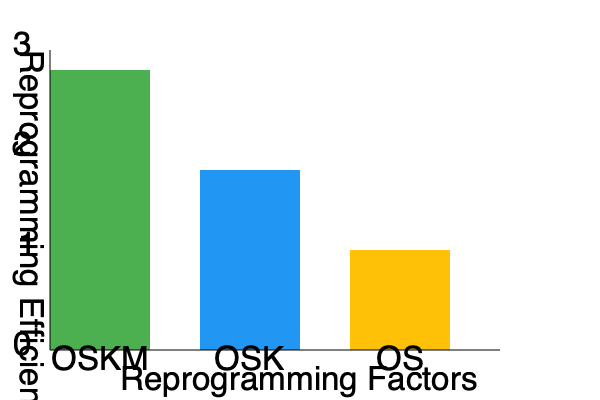Based on the bar chart showing the reprogramming efficiency of different factor combinations, which of the following statements is correct regarding the OSKM (Oct4, Sox2, Klf4, c-Myc) combination compared to the other factor combinations? To answer this question, we need to analyze the bar chart and compare the reprogramming efficiencies of the different factor combinations:

1. Identify the factor combinations:
   - OSKM: Oct4, Sox2, Klf4, c-Myc (4 factors)
   - OSK: Oct4, Sox2, Klf4 (3 factors)
   - OS: Oct4, Sox2 (2 factors)

2. Compare the heights of the bars:
   - OSKM (leftmost bar) has the highest bar, reaching close to 3% efficiency
   - OSK (middle bar) has the second-highest bar, reaching about 1.8% efficiency
   - OS (rightmost bar) has the lowest bar, reaching about 1% efficiency

3. Analyze the relationship between factor number and efficiency:
   - As the number of factors decreases from 4 to 2, the reprogramming efficiency also decreases
   - OSKM (4 factors) shows the highest efficiency
   - OSK (3 factors) shows intermediate efficiency
   - OS (2 factors) shows the lowest efficiency

4. Conclude:
   The OSKM combination demonstrates the highest reprogramming efficiency among the three factor combinations shown. This suggests that the presence of all four factors (Oct4, Sox2, Klf4, and c-Myc) results in more efficient reprogramming compared to combinations with fewer factors.
Answer: OSKM shows the highest reprogramming efficiency. 